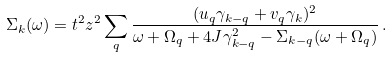Convert formula to latex. <formula><loc_0><loc_0><loc_500><loc_500>\Sigma _ { k } ( \omega ) = t ^ { 2 } z ^ { 2 } \sum _ { q } \frac { ( u _ { q } \gamma _ { k - q } + v _ { q } \gamma _ { k } ) ^ { 2 } } { \omega + \Omega _ { q } + 4 J \gamma _ { k - q } ^ { 2 } - \Sigma _ { k - q } ( \omega + \Omega _ { q } ) } \, .</formula> 